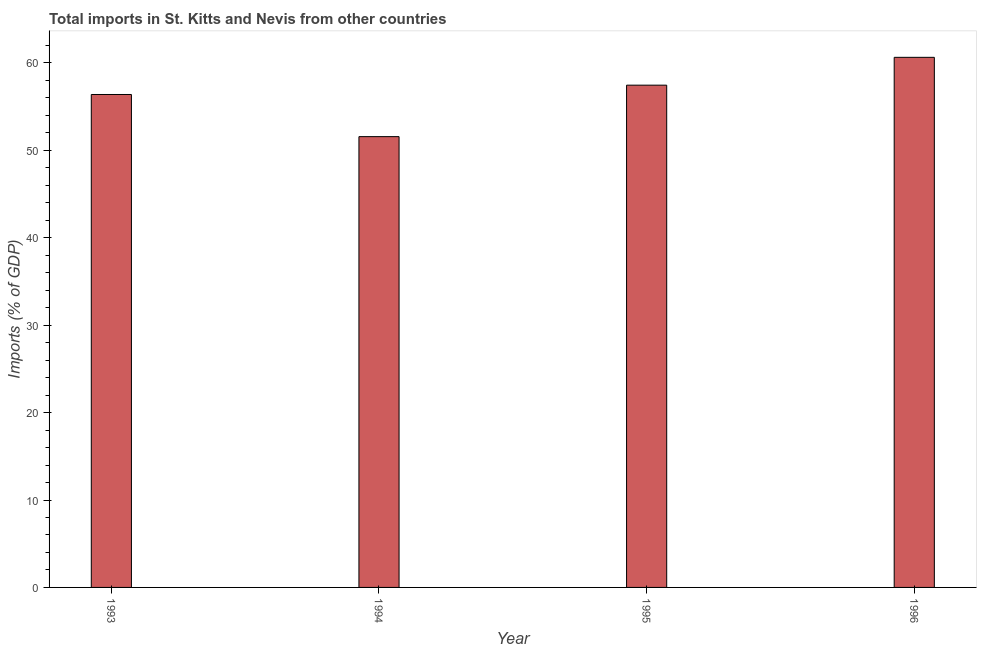Does the graph contain grids?
Keep it short and to the point. No. What is the title of the graph?
Provide a short and direct response. Total imports in St. Kitts and Nevis from other countries. What is the label or title of the X-axis?
Your answer should be compact. Year. What is the label or title of the Y-axis?
Keep it short and to the point. Imports (% of GDP). What is the total imports in 1994?
Give a very brief answer. 51.57. Across all years, what is the maximum total imports?
Ensure brevity in your answer.  60.64. Across all years, what is the minimum total imports?
Make the answer very short. 51.57. In which year was the total imports maximum?
Make the answer very short. 1996. What is the sum of the total imports?
Ensure brevity in your answer.  226.04. What is the difference between the total imports in 1994 and 1996?
Offer a terse response. -9.07. What is the average total imports per year?
Offer a very short reply. 56.51. What is the median total imports?
Ensure brevity in your answer.  56.92. In how many years, is the total imports greater than 46 %?
Your answer should be very brief. 4. What is the ratio of the total imports in 1995 to that in 1996?
Offer a very short reply. 0.95. Is the total imports in 1993 less than that in 1996?
Your answer should be very brief. Yes. What is the difference between the highest and the second highest total imports?
Ensure brevity in your answer.  3.18. What is the difference between the highest and the lowest total imports?
Your answer should be compact. 9.07. How many bars are there?
Ensure brevity in your answer.  4. Are all the bars in the graph horizontal?
Keep it short and to the point. No. What is the difference between two consecutive major ticks on the Y-axis?
Your answer should be compact. 10. Are the values on the major ticks of Y-axis written in scientific E-notation?
Keep it short and to the point. No. What is the Imports (% of GDP) in 1993?
Provide a succinct answer. 56.39. What is the Imports (% of GDP) in 1994?
Ensure brevity in your answer.  51.57. What is the Imports (% of GDP) of 1995?
Offer a terse response. 57.45. What is the Imports (% of GDP) in 1996?
Your response must be concise. 60.64. What is the difference between the Imports (% of GDP) in 1993 and 1994?
Offer a very short reply. 4.82. What is the difference between the Imports (% of GDP) in 1993 and 1995?
Ensure brevity in your answer.  -1.07. What is the difference between the Imports (% of GDP) in 1993 and 1996?
Provide a succinct answer. -4.25. What is the difference between the Imports (% of GDP) in 1994 and 1995?
Make the answer very short. -5.89. What is the difference between the Imports (% of GDP) in 1994 and 1996?
Give a very brief answer. -9.07. What is the difference between the Imports (% of GDP) in 1995 and 1996?
Keep it short and to the point. -3.18. What is the ratio of the Imports (% of GDP) in 1993 to that in 1994?
Your response must be concise. 1.09. What is the ratio of the Imports (% of GDP) in 1993 to that in 1995?
Your answer should be very brief. 0.98. What is the ratio of the Imports (% of GDP) in 1994 to that in 1995?
Your response must be concise. 0.9. What is the ratio of the Imports (% of GDP) in 1995 to that in 1996?
Make the answer very short. 0.95. 